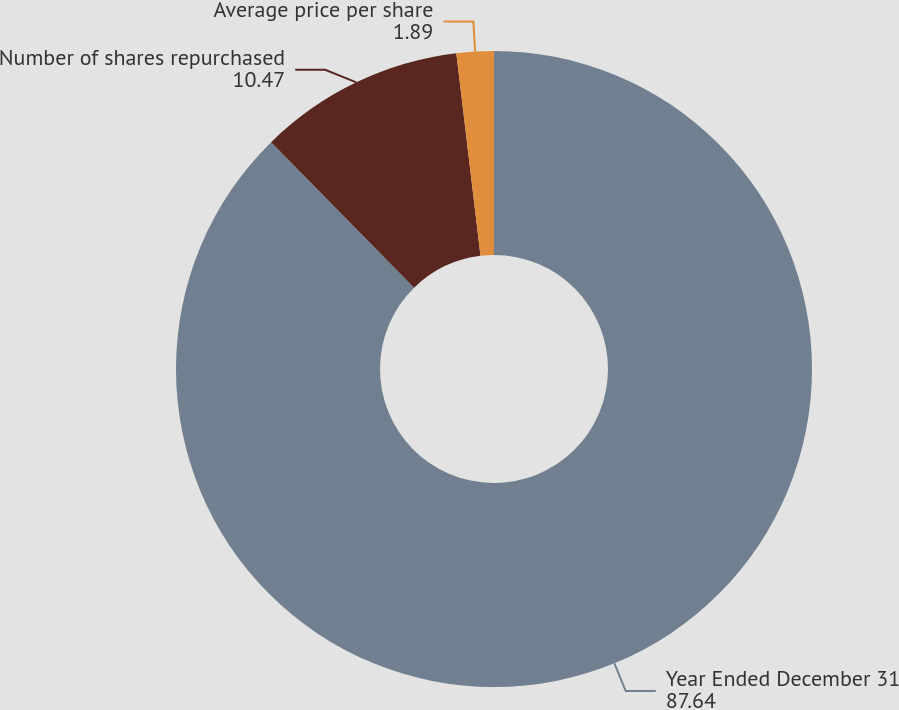Convert chart to OTSL. <chart><loc_0><loc_0><loc_500><loc_500><pie_chart><fcel>Year Ended December 31<fcel>Number of shares repurchased<fcel>Average price per share<nl><fcel>87.64%<fcel>10.47%<fcel>1.89%<nl></chart> 